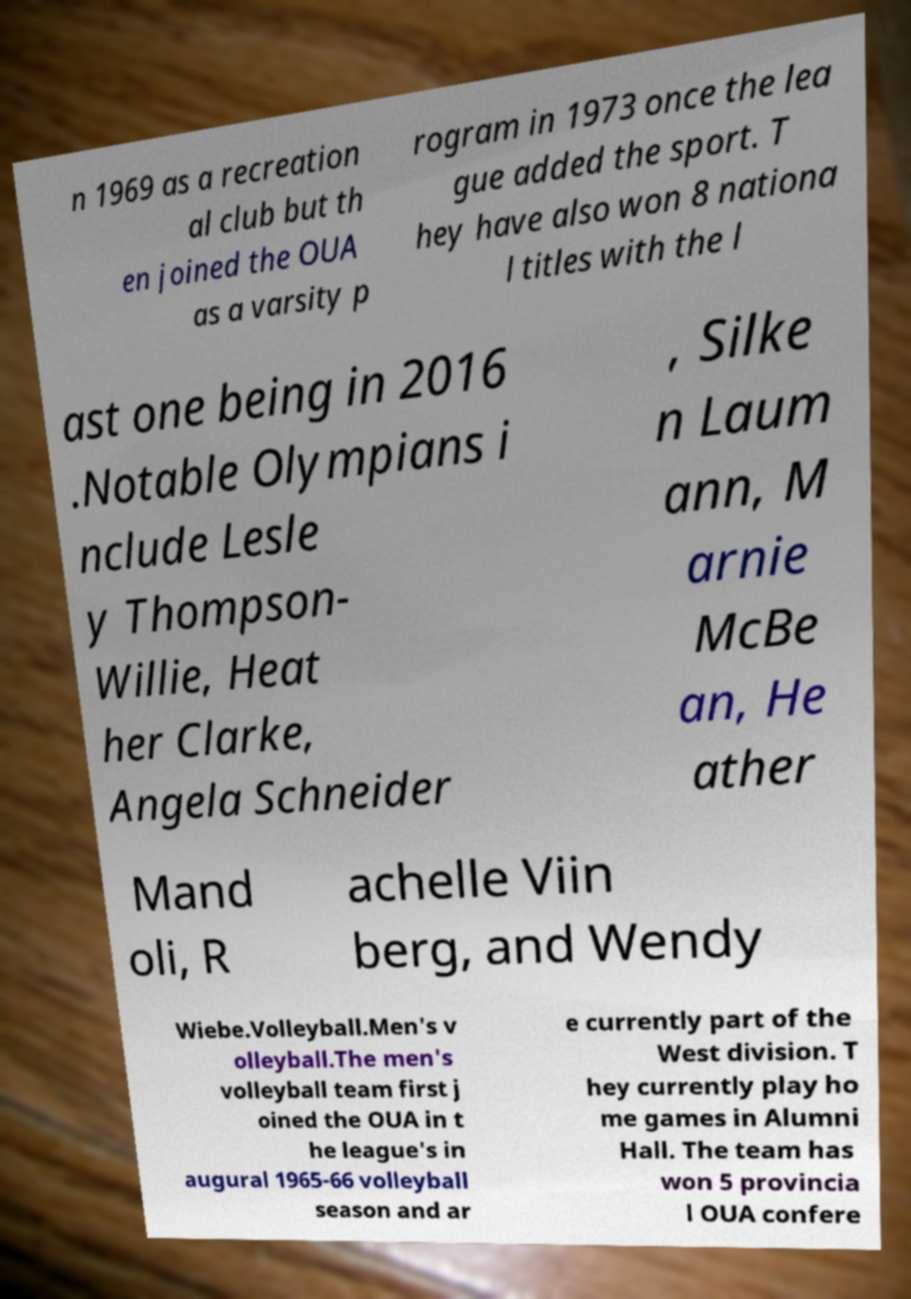Could you extract and type out the text from this image? n 1969 as a recreation al club but th en joined the OUA as a varsity p rogram in 1973 once the lea gue added the sport. T hey have also won 8 nationa l titles with the l ast one being in 2016 .Notable Olympians i nclude Lesle y Thompson- Willie, Heat her Clarke, Angela Schneider , Silke n Laum ann, M arnie McBe an, He ather Mand oli, R achelle Viin berg, and Wendy Wiebe.Volleyball.Men's v olleyball.The men's volleyball team first j oined the OUA in t he league's in augural 1965-66 volleyball season and ar e currently part of the West division. T hey currently play ho me games in Alumni Hall. The team has won 5 provincia l OUA confere 